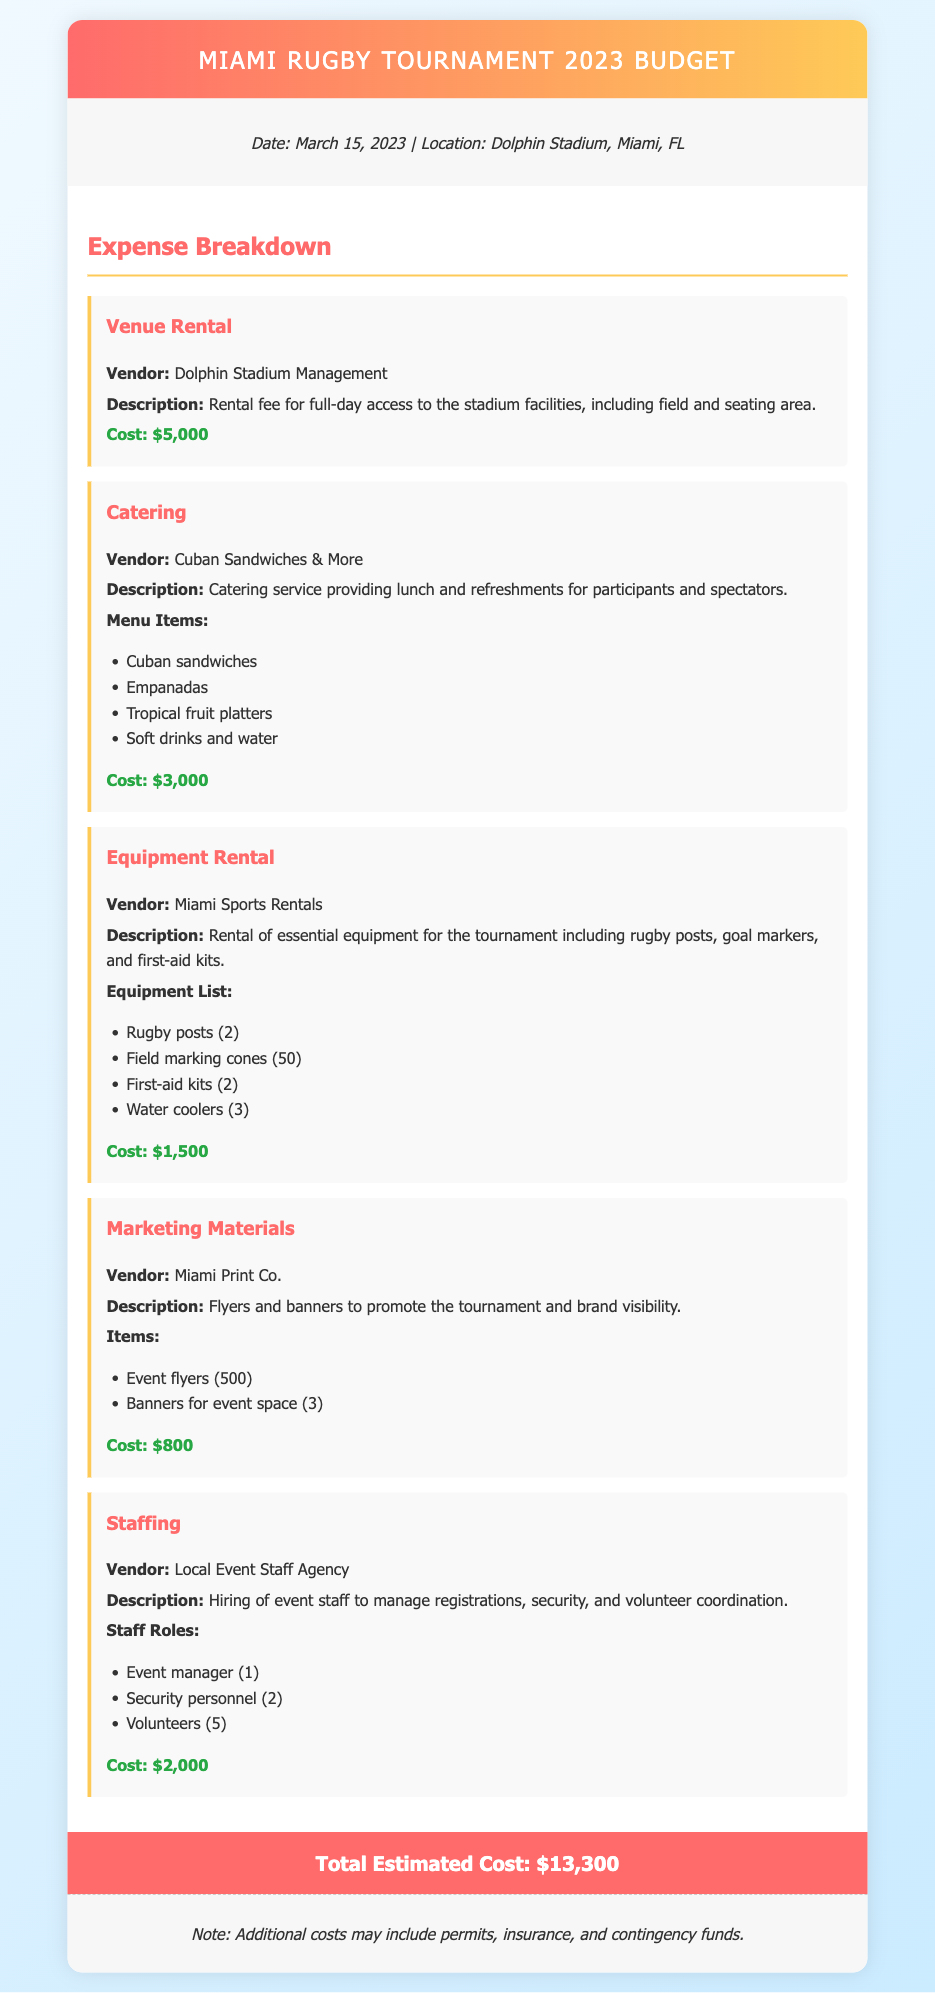What is the date of the tournament? The date of the tournament is explicitly mentioned in the document as March 15, 2023.
Answer: March 15, 2023 What is the venue for the tournament? The venue where the event is planned to be held is stated as Dolphin Stadium, Miami, FL.
Answer: Dolphin Stadium, Miami, FL How much does the venue rental cost? The document specifies the cost of venue rental as $5,000.
Answer: $5,000 Who is the catering vendor? The catering vendor providing food for the event is named in the document as Cuban Sandwiches & More.
Answer: Cuban Sandwiches & More What is the total estimated cost of the event? The total estimated cost is listed at the end of the document, which combines all expenses.
Answer: $13,300 How many rugby posts are rented for the tournament? The rental information specifies that 2 rugby posts will be provided for the event.
Answer: 2 What type of food is included in the catering service? The catering service includes Cuban sandwiches, empanadas, tropical fruit platters, and soft drinks and water.
Answer: Cuban sandwiches, empanadas, tropical fruit platters, soft drinks and water How many volunteers are hired for the event? The document mentions that 5 volunteers are hired for the event.
Answer: 5 What is one of the marketing materials mentioned? The marketing materials include event flyers, specifically noted as 500 flyers in the document.
Answer: Event flyers (500) 